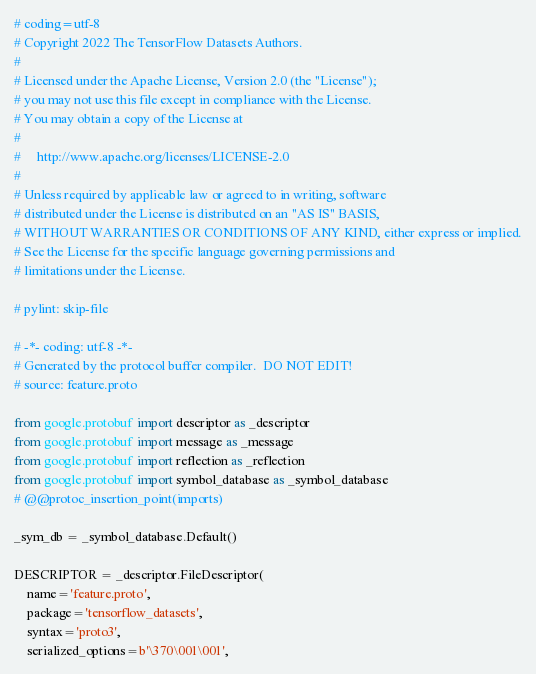Convert code to text. <code><loc_0><loc_0><loc_500><loc_500><_Python_># coding=utf-8
# Copyright 2022 The TensorFlow Datasets Authors.
#
# Licensed under the Apache License, Version 2.0 (the "License");
# you may not use this file except in compliance with the License.
# You may obtain a copy of the License at
#
#     http://www.apache.org/licenses/LICENSE-2.0
#
# Unless required by applicable law or agreed to in writing, software
# distributed under the License is distributed on an "AS IS" BASIS,
# WITHOUT WARRANTIES OR CONDITIONS OF ANY KIND, either express or implied.
# See the License for the specific language governing permissions and
# limitations under the License.

# pylint: skip-file

# -*- coding: utf-8 -*-
# Generated by the protocol buffer compiler.  DO NOT EDIT!
# source: feature.proto

from google.protobuf import descriptor as _descriptor
from google.protobuf import message as _message
from google.protobuf import reflection as _reflection
from google.protobuf import symbol_database as _symbol_database
# @@protoc_insertion_point(imports)

_sym_db = _symbol_database.Default()

DESCRIPTOR = _descriptor.FileDescriptor(
    name='feature.proto',
    package='tensorflow_datasets',
    syntax='proto3',
    serialized_options=b'\370\001\001',</code> 